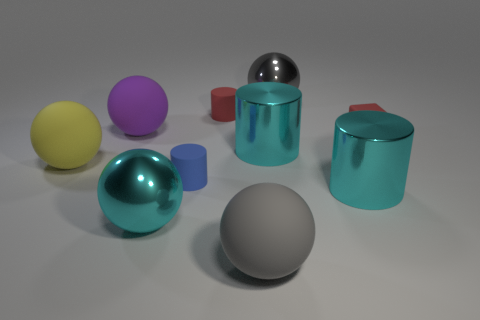Is the shape of the big yellow rubber object the same as the big gray matte thing?
Offer a terse response. Yes. What size is the red matte cylinder?
Give a very brief answer. Small. Are there any small red blocks left of the purple rubber thing?
Give a very brief answer. No. Is there a cyan rubber object that has the same size as the gray shiny sphere?
Offer a very short reply. No. What color is the block that is made of the same material as the small blue cylinder?
Provide a succinct answer. Red. What material is the large cyan sphere?
Your response must be concise. Metal. The tiny blue rubber object has what shape?
Your answer should be very brief. Cylinder. How many large metal balls have the same color as the rubber cube?
Provide a succinct answer. 0. What is the material of the large gray ball that is behind the metal thing that is in front of the metal object right of the big gray shiny object?
Your response must be concise. Metal. How many purple things are either small matte cylinders or blocks?
Your answer should be compact. 0. 